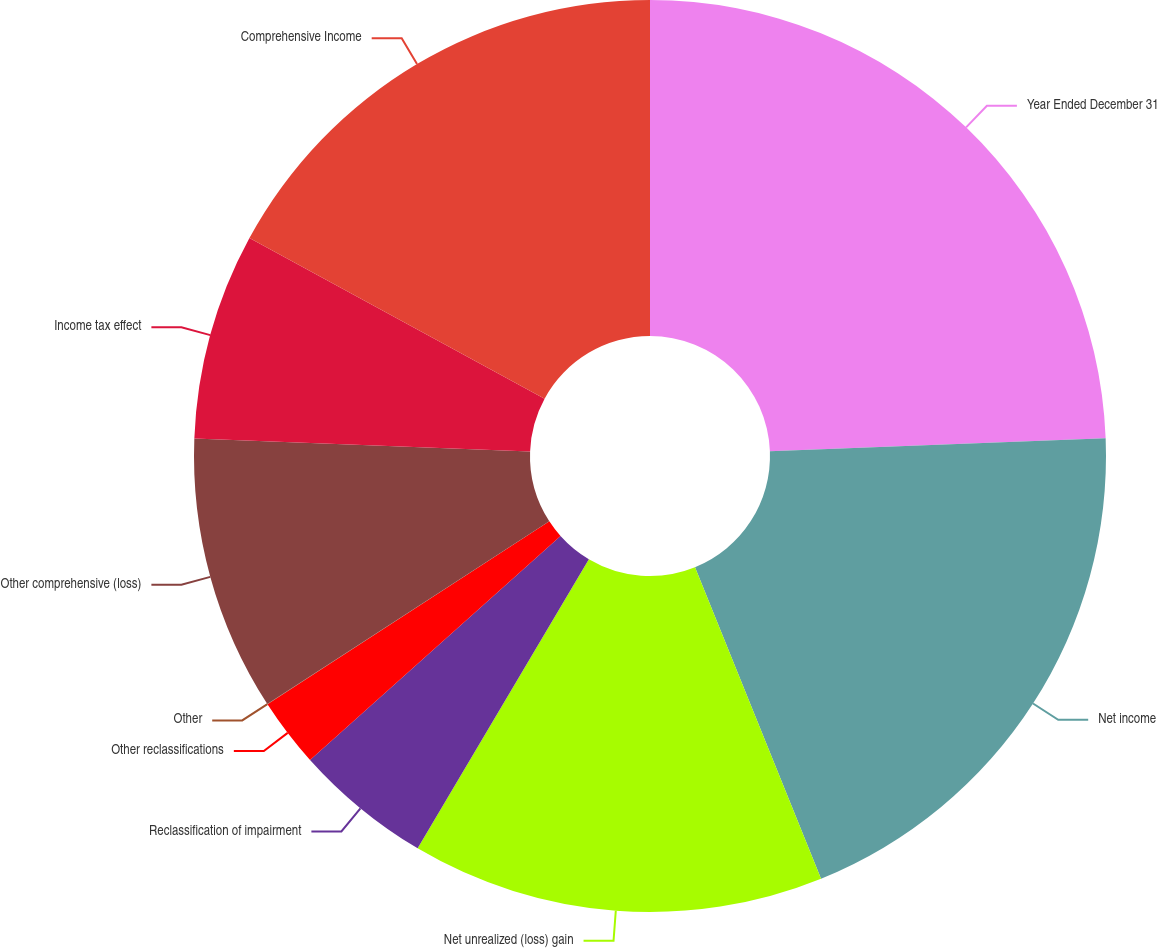Convert chart to OTSL. <chart><loc_0><loc_0><loc_500><loc_500><pie_chart><fcel>Year Ended December 31<fcel>Net income<fcel>Net unrealized (loss) gain<fcel>Reclassification of impairment<fcel>Other reclassifications<fcel>Other<fcel>Other comprehensive (loss)<fcel>Income tax effect<fcel>Comprehensive Income<nl><fcel>24.38%<fcel>19.5%<fcel>14.63%<fcel>4.88%<fcel>2.45%<fcel>0.01%<fcel>9.76%<fcel>7.32%<fcel>17.07%<nl></chart> 